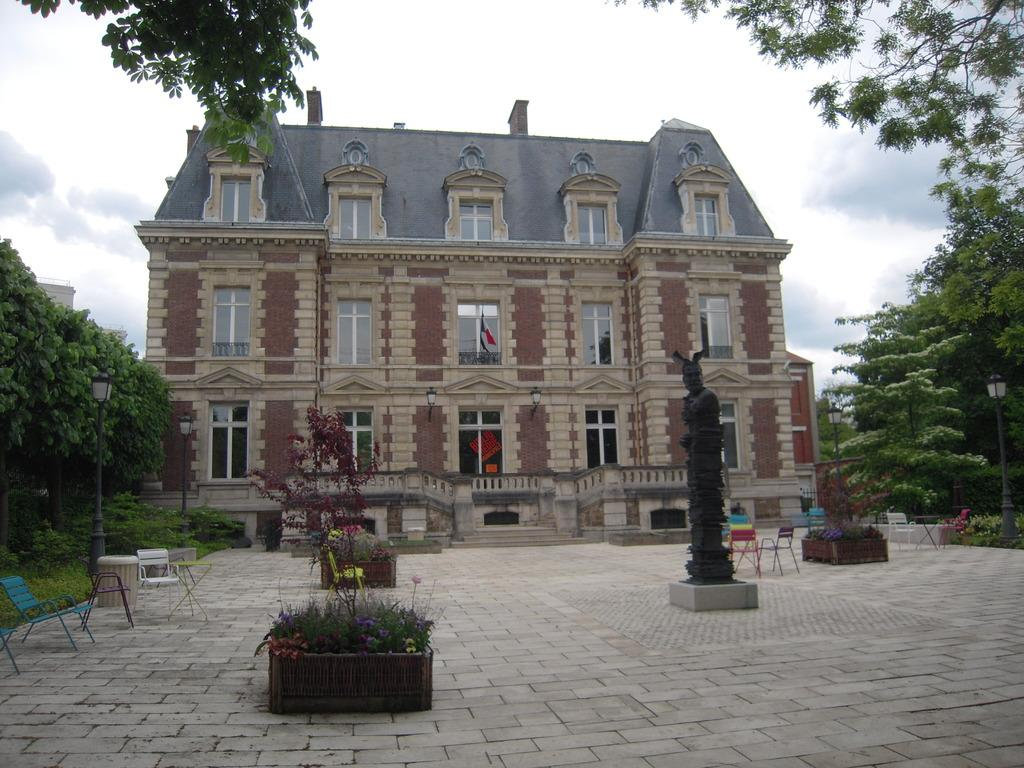What type of structures can be seen in the image? There are buildings in the image. What other objects are present in the image? There are statues, chairs, a side table, a street pole, and a street light in the image. What type of vegetation is visible in the image? There are plants and trees in the image. What is visible in the sky in the image? The sky is visible in the image, and there are clouds in the sky. Can you tell me how many friends are helping the cart in the image? There is no cart or friends present in the image. What type of assistance do the statues provide in the image? The statues are not providing any assistance in the image; they are stationary objects. 